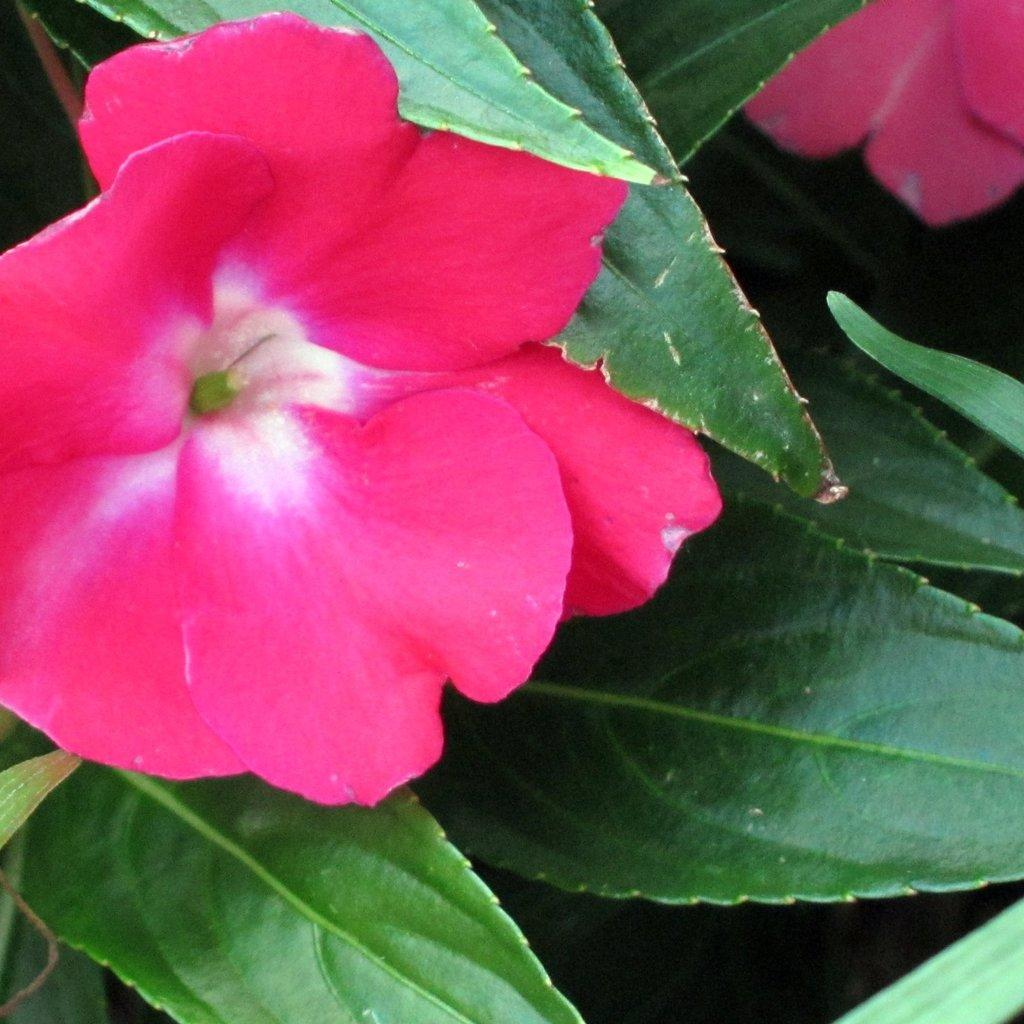What type of plant is in the image? There is a plant in the image. How many flowers are on the plant? The plant has two flowers. What color are the flowers? The flowers are pink in color. What else can be seen on the plant besides the flowers? There are leaves on the plant. What color are the leaves? The leaves are green in color. What type of apparel is the plant wearing in the image? There is no apparel present in the image; it is a plant with flowers and leaves. 